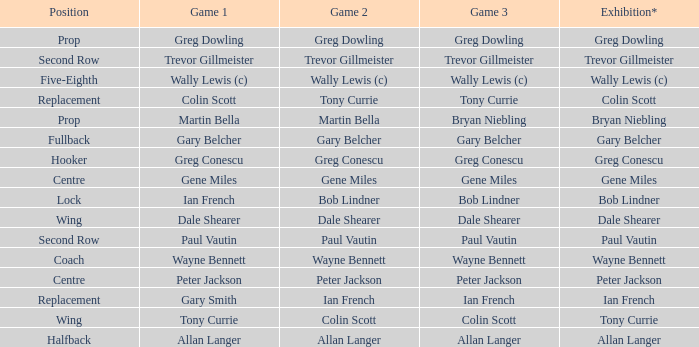What game 1 has bob lindner as game 2? Ian French. 